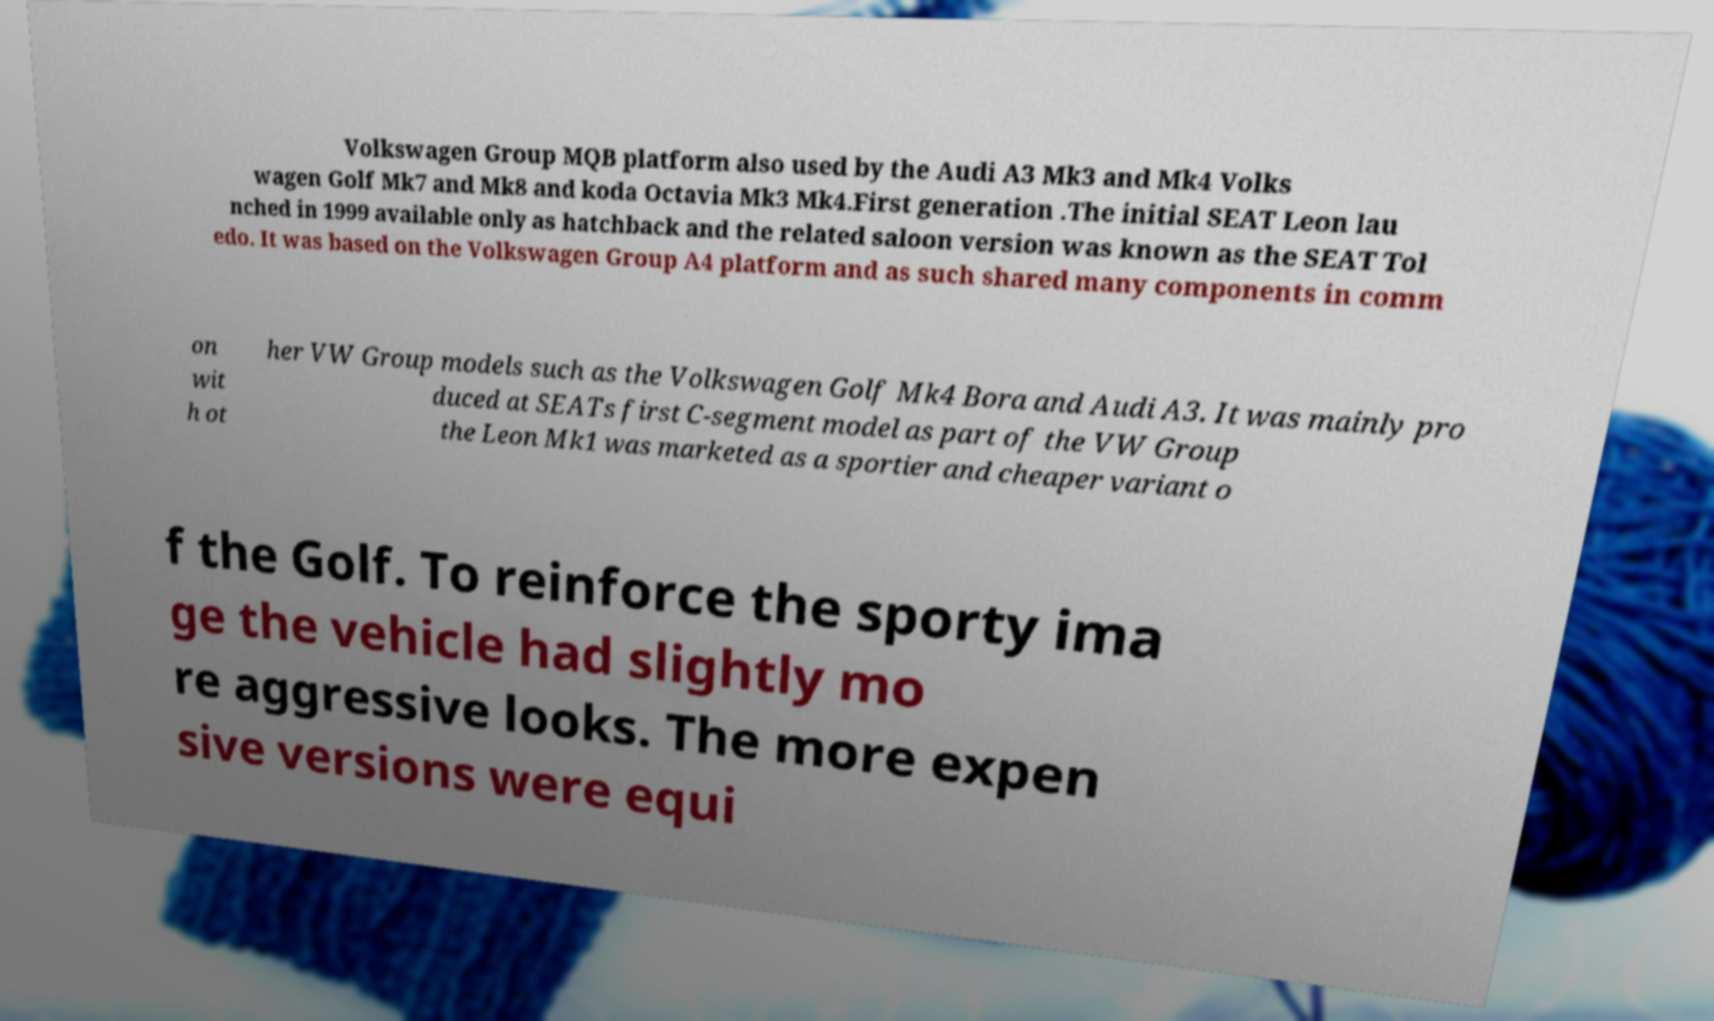There's text embedded in this image that I need extracted. Can you transcribe it verbatim? Volkswagen Group MQB platform also used by the Audi A3 Mk3 and Mk4 Volks wagen Golf Mk7 and Mk8 and koda Octavia Mk3 Mk4.First generation .The initial SEAT Leon lau nched in 1999 available only as hatchback and the related saloon version was known as the SEAT Tol edo. It was based on the Volkswagen Group A4 platform and as such shared many components in comm on wit h ot her VW Group models such as the Volkswagen Golf Mk4 Bora and Audi A3. It was mainly pro duced at SEATs first C-segment model as part of the VW Group the Leon Mk1 was marketed as a sportier and cheaper variant o f the Golf. To reinforce the sporty ima ge the vehicle had slightly mo re aggressive looks. The more expen sive versions were equi 